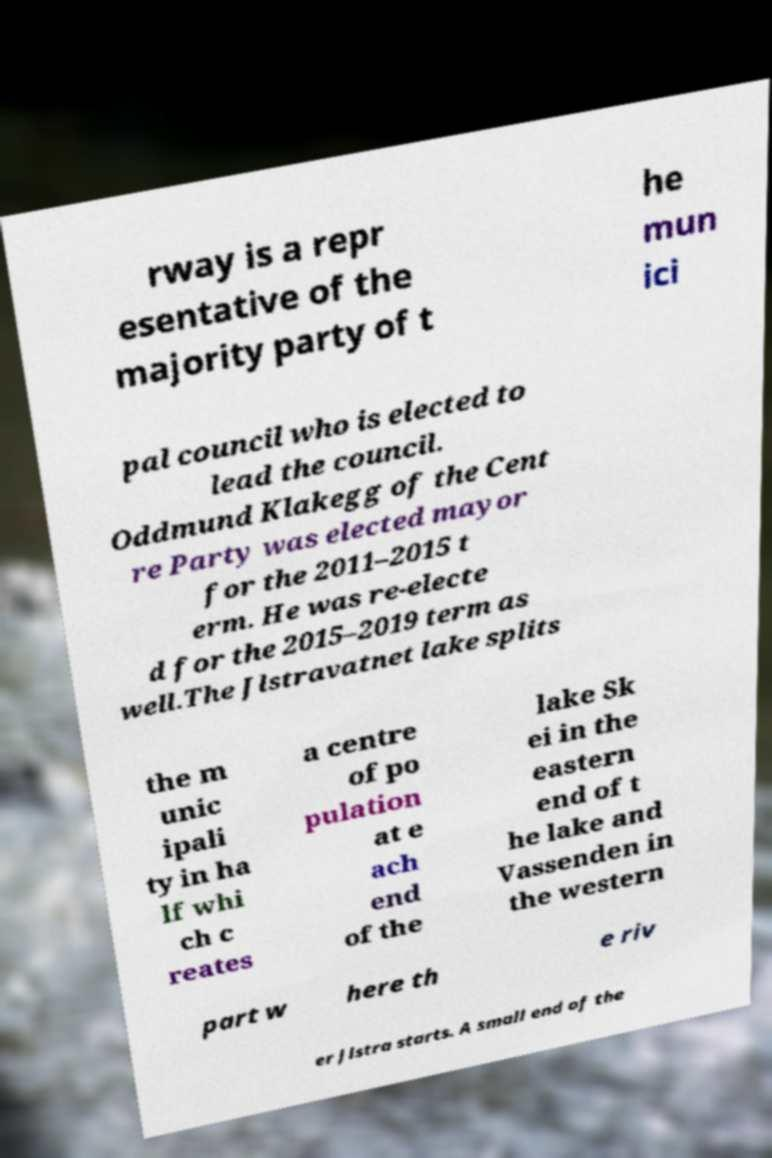Can you read and provide the text displayed in the image?This photo seems to have some interesting text. Can you extract and type it out for me? rway is a repr esentative of the majority party of t he mun ici pal council who is elected to lead the council. Oddmund Klakegg of the Cent re Party was elected mayor for the 2011–2015 t erm. He was re-electe d for the 2015–2019 term as well.The Jlstravatnet lake splits the m unic ipali ty in ha lf whi ch c reates a centre of po pulation at e ach end of the lake Sk ei in the eastern end of t he lake and Vassenden in the western part w here th e riv er Jlstra starts. A small end of the 